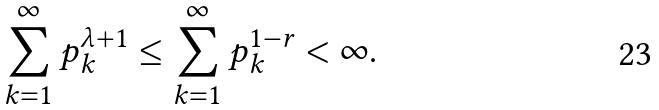Convert formula to latex. <formula><loc_0><loc_0><loc_500><loc_500>\sum _ { k = 1 } ^ { \infty } p _ { k } ^ { \lambda + 1 } \leq \sum _ { k = 1 } ^ { \infty } p _ { k } ^ { 1 - r } < \infty .</formula> 